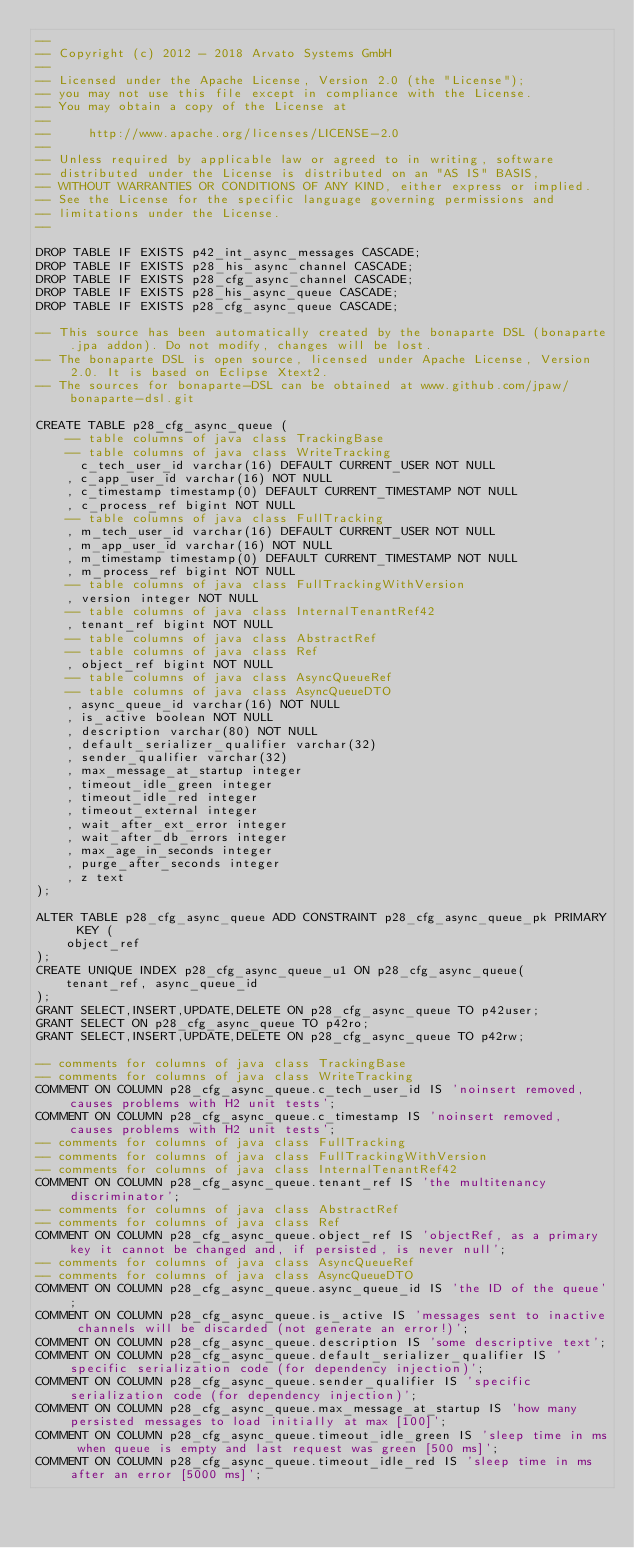<code> <loc_0><loc_0><loc_500><loc_500><_SQL_>--
-- Copyright (c) 2012 - 2018 Arvato Systems GmbH
--
-- Licensed under the Apache License, Version 2.0 (the "License");
-- you may not use this file except in compliance with the License.
-- You may obtain a copy of the License at
--
--     http://www.apache.org/licenses/LICENSE-2.0
--
-- Unless required by applicable law or agreed to in writing, software
-- distributed under the License is distributed on an "AS IS" BASIS,
-- WITHOUT WARRANTIES OR CONDITIONS OF ANY KIND, either express or implied.
-- See the License for the specific language governing permissions and
-- limitations under the License.
--

DROP TABLE IF EXISTS p42_int_async_messages CASCADE;
DROP TABLE IF EXISTS p28_his_async_channel CASCADE;
DROP TABLE IF EXISTS p28_cfg_async_channel CASCADE;
DROP TABLE IF EXISTS p28_his_async_queue CASCADE;
DROP TABLE IF EXISTS p28_cfg_async_queue CASCADE;

-- This source has been automatically created by the bonaparte DSL (bonaparte.jpa addon). Do not modify, changes will be lost.
-- The bonaparte DSL is open source, licensed under Apache License, Version 2.0. It is based on Eclipse Xtext2.
-- The sources for bonaparte-DSL can be obtained at www.github.com/jpaw/bonaparte-dsl.git

CREATE TABLE p28_cfg_async_queue (
    -- table columns of java class TrackingBase
    -- table columns of java class WriteTracking
      c_tech_user_id varchar(16) DEFAULT CURRENT_USER NOT NULL
    , c_app_user_id varchar(16) NOT NULL
    , c_timestamp timestamp(0) DEFAULT CURRENT_TIMESTAMP NOT NULL
    , c_process_ref bigint NOT NULL
    -- table columns of java class FullTracking
    , m_tech_user_id varchar(16) DEFAULT CURRENT_USER NOT NULL
    , m_app_user_id varchar(16) NOT NULL
    , m_timestamp timestamp(0) DEFAULT CURRENT_TIMESTAMP NOT NULL
    , m_process_ref bigint NOT NULL
    -- table columns of java class FullTrackingWithVersion
    , version integer NOT NULL
    -- table columns of java class InternalTenantRef42
    , tenant_ref bigint NOT NULL
    -- table columns of java class AbstractRef
    -- table columns of java class Ref
    , object_ref bigint NOT NULL
    -- table columns of java class AsyncQueueRef
    -- table columns of java class AsyncQueueDTO
    , async_queue_id varchar(16) NOT NULL
    , is_active boolean NOT NULL
    , description varchar(80) NOT NULL
    , default_serializer_qualifier varchar(32)
    , sender_qualifier varchar(32)
    , max_message_at_startup integer
    , timeout_idle_green integer
    , timeout_idle_red integer
    , timeout_external integer
    , wait_after_ext_error integer
    , wait_after_db_errors integer
    , max_age_in_seconds integer
    , purge_after_seconds integer
    , z text
);

ALTER TABLE p28_cfg_async_queue ADD CONSTRAINT p28_cfg_async_queue_pk PRIMARY KEY (
    object_ref
);
CREATE UNIQUE INDEX p28_cfg_async_queue_u1 ON p28_cfg_async_queue(
    tenant_ref, async_queue_id
);
GRANT SELECT,INSERT,UPDATE,DELETE ON p28_cfg_async_queue TO p42user;
GRANT SELECT ON p28_cfg_async_queue TO p42ro;
GRANT SELECT,INSERT,UPDATE,DELETE ON p28_cfg_async_queue TO p42rw;

-- comments for columns of java class TrackingBase
-- comments for columns of java class WriteTracking
COMMENT ON COLUMN p28_cfg_async_queue.c_tech_user_id IS 'noinsert removed, causes problems with H2 unit tests';
COMMENT ON COLUMN p28_cfg_async_queue.c_timestamp IS 'noinsert removed, causes problems with H2 unit tests';
-- comments for columns of java class FullTracking
-- comments for columns of java class FullTrackingWithVersion
-- comments for columns of java class InternalTenantRef42
COMMENT ON COLUMN p28_cfg_async_queue.tenant_ref IS 'the multitenancy discriminator';
-- comments for columns of java class AbstractRef
-- comments for columns of java class Ref
COMMENT ON COLUMN p28_cfg_async_queue.object_ref IS 'objectRef, as a primary key it cannot be changed and, if persisted, is never null';
-- comments for columns of java class AsyncQueueRef
-- comments for columns of java class AsyncQueueDTO
COMMENT ON COLUMN p28_cfg_async_queue.async_queue_id IS 'the ID of the queue';
COMMENT ON COLUMN p28_cfg_async_queue.is_active IS 'messages sent to inactive channels will be discarded (not generate an error!)';
COMMENT ON COLUMN p28_cfg_async_queue.description IS 'some descriptive text';
COMMENT ON COLUMN p28_cfg_async_queue.default_serializer_qualifier IS 'specific serialization code (for dependency injection)';
COMMENT ON COLUMN p28_cfg_async_queue.sender_qualifier IS 'specific serialization code (for dependency injection)';
COMMENT ON COLUMN p28_cfg_async_queue.max_message_at_startup IS 'how many persisted messages to load initially at max [100]';
COMMENT ON COLUMN p28_cfg_async_queue.timeout_idle_green IS 'sleep time in ms when queue is empty and last request was green [500 ms]';
COMMENT ON COLUMN p28_cfg_async_queue.timeout_idle_red IS 'sleep time in ms after an error [5000 ms]';</code> 